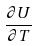<formula> <loc_0><loc_0><loc_500><loc_500>\frac { \partial U } { \partial T }</formula> 